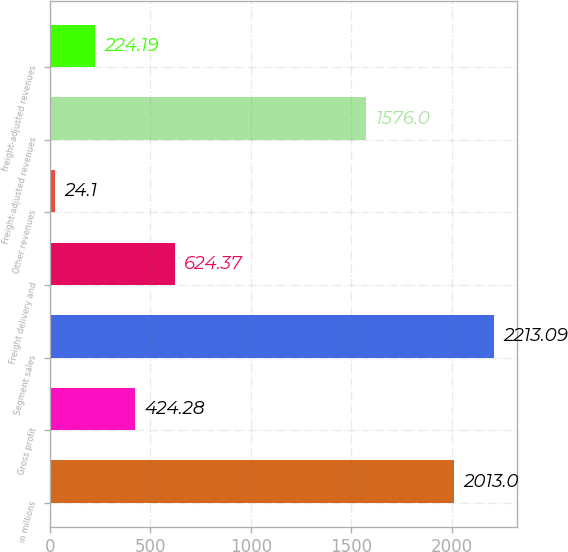<chart> <loc_0><loc_0><loc_500><loc_500><bar_chart><fcel>in millions<fcel>Gross profit<fcel>Segment sales<fcel>Freight delivery and<fcel>Other revenues<fcel>Freight-adjusted revenues<fcel>freight-adjusted revenues<nl><fcel>2013<fcel>424.28<fcel>2213.09<fcel>624.37<fcel>24.1<fcel>1576<fcel>224.19<nl></chart> 